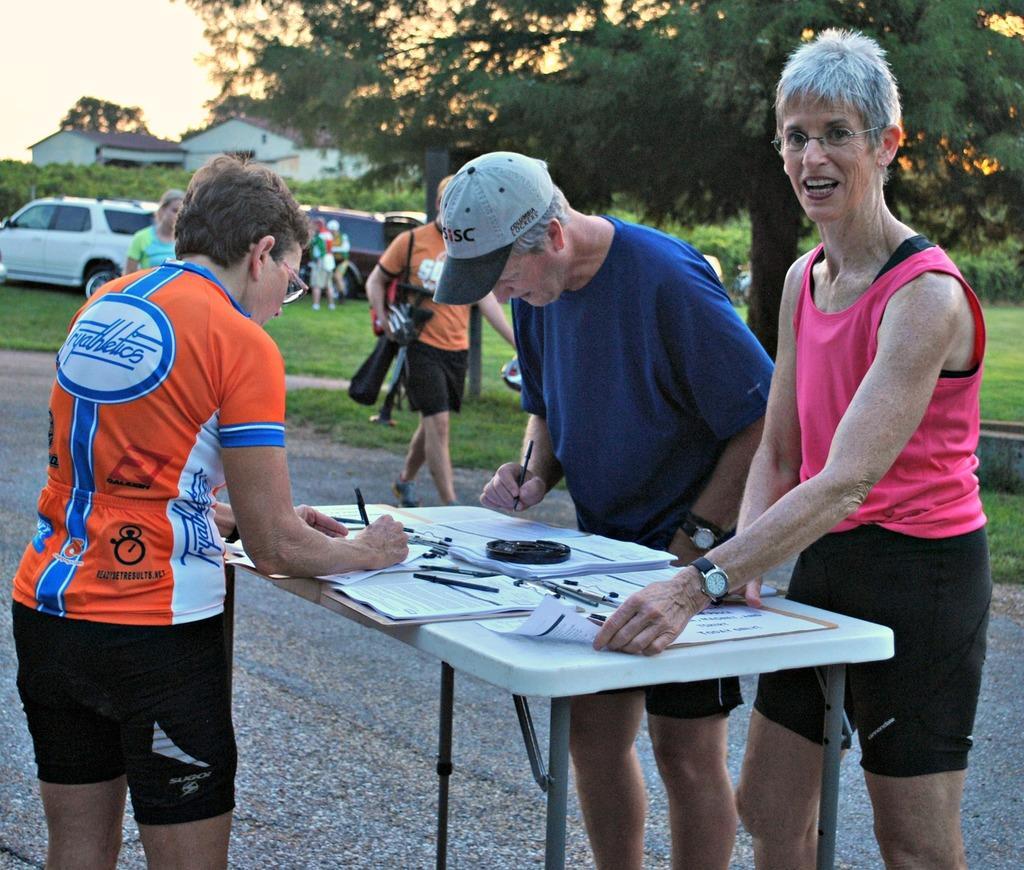Please provide a concise description of this image. In this image i can see i can see a group of people are standing on the road in front of table. On the table we have few objects on it. I can also see there is a tree and a house. 